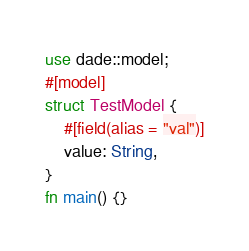Convert code to text. <code><loc_0><loc_0><loc_500><loc_500><_Rust_>use dade::model;
#[model]
struct TestModel {
    #[field(alias = "val")]
    value: String,
}
fn main() {}
</code> 